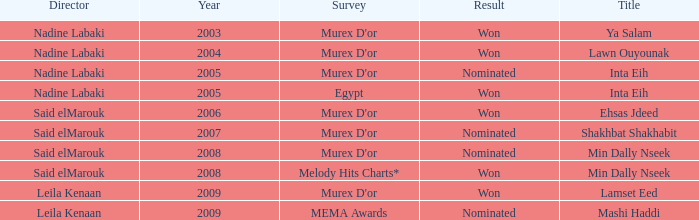What is the title for the Murex D'or survey, after 2005, Said Elmarouk as director, and was nominated? Shakhbat Shakhabit, Min Dally Nseek. 